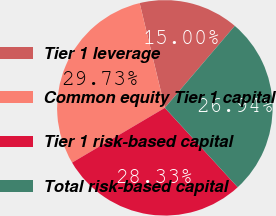Convert chart to OTSL. <chart><loc_0><loc_0><loc_500><loc_500><pie_chart><fcel>Tier 1 leverage<fcel>Common equity Tier 1 capital<fcel>Tier 1 risk-based capital<fcel>Total risk-based capital<nl><fcel>15.0%<fcel>29.73%<fcel>28.33%<fcel>26.94%<nl></chart> 